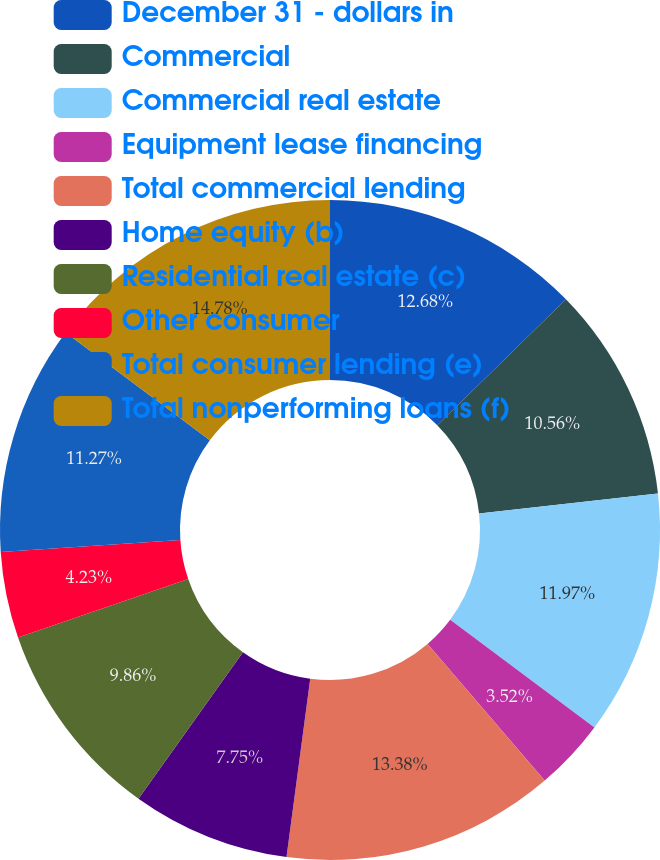Convert chart. <chart><loc_0><loc_0><loc_500><loc_500><pie_chart><fcel>December 31 - dollars in<fcel>Commercial<fcel>Commercial real estate<fcel>Equipment lease financing<fcel>Total commercial lending<fcel>Home equity (b)<fcel>Residential real estate (c)<fcel>Other consumer<fcel>Total consumer lending (e)<fcel>Total nonperforming loans (f)<nl><fcel>12.68%<fcel>10.56%<fcel>11.97%<fcel>3.52%<fcel>13.38%<fcel>7.75%<fcel>9.86%<fcel>4.23%<fcel>11.27%<fcel>14.79%<nl></chart> 